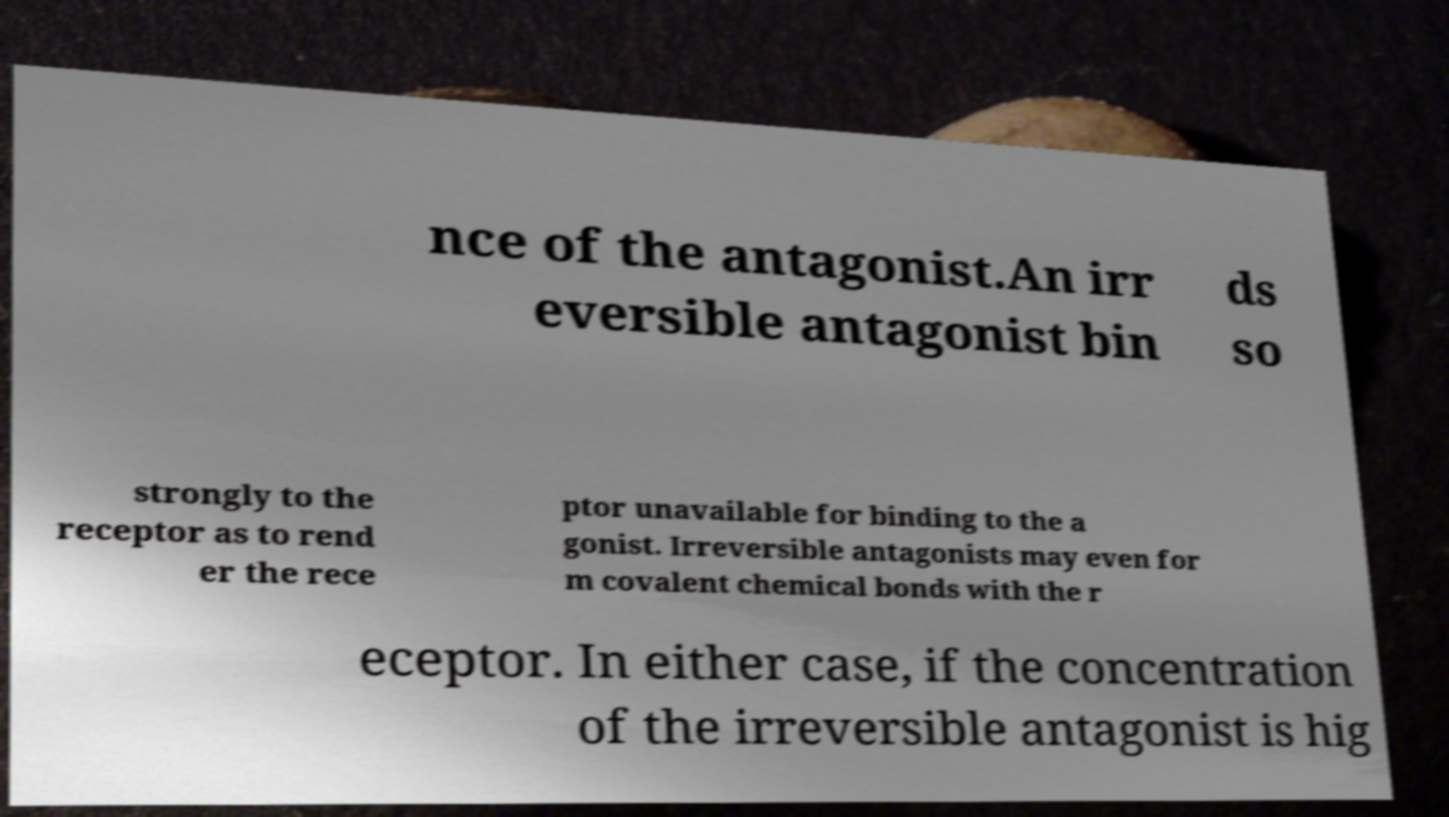For documentation purposes, I need the text within this image transcribed. Could you provide that? nce of the antagonist.An irr eversible antagonist bin ds so strongly to the receptor as to rend er the rece ptor unavailable for binding to the a gonist. Irreversible antagonists may even for m covalent chemical bonds with the r eceptor. In either case, if the concentration of the irreversible antagonist is hig 